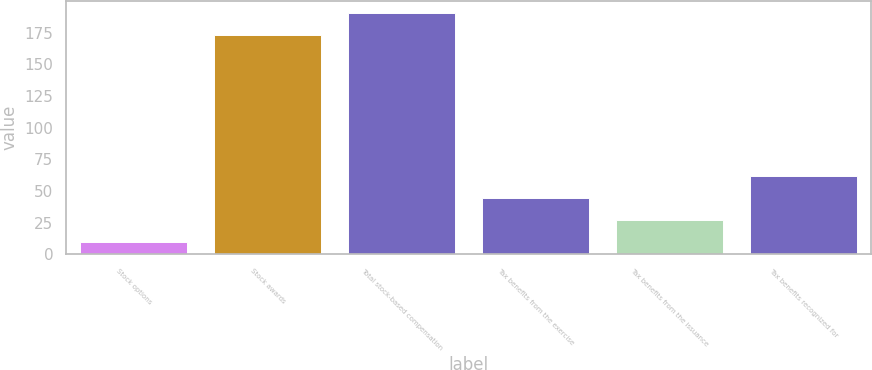Convert chart. <chart><loc_0><loc_0><loc_500><loc_500><bar_chart><fcel>Stock options<fcel>Stock awards<fcel>Total stock-based compensation<fcel>Tax benefits from the exercise<fcel>Tax benefits from the issuance<fcel>Tax benefits recognized for<nl><fcel>10<fcel>173<fcel>190.3<fcel>44.6<fcel>27.3<fcel>61.9<nl></chart> 